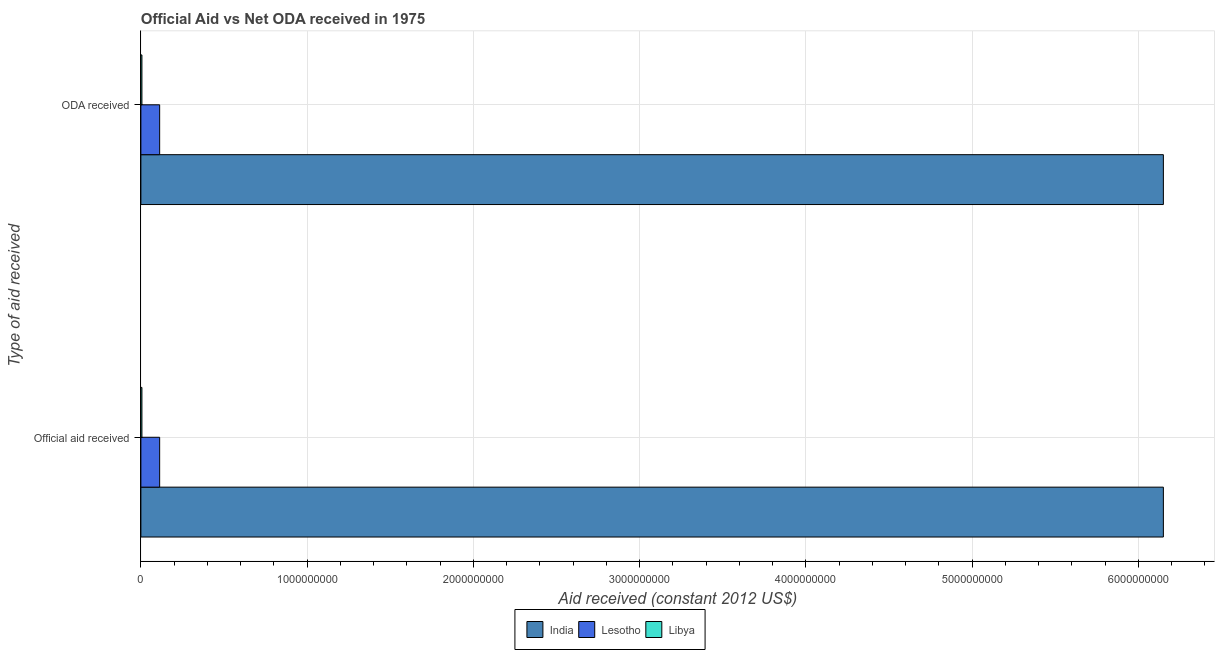How many different coloured bars are there?
Keep it short and to the point. 3. How many groups of bars are there?
Make the answer very short. 2. Are the number of bars per tick equal to the number of legend labels?
Offer a very short reply. Yes. How many bars are there on the 2nd tick from the top?
Provide a succinct answer. 3. What is the label of the 2nd group of bars from the top?
Make the answer very short. Official aid received. What is the official aid received in Libya?
Provide a succinct answer. 6.21e+06. Across all countries, what is the maximum oda received?
Offer a very short reply. 6.15e+09. Across all countries, what is the minimum oda received?
Your answer should be compact. 6.21e+06. In which country was the oda received maximum?
Offer a terse response. India. In which country was the official aid received minimum?
Keep it short and to the point. Libya. What is the total oda received in the graph?
Keep it short and to the point. 6.27e+09. What is the difference between the official aid received in India and that in Lesotho?
Keep it short and to the point. 6.04e+09. What is the difference between the oda received in Lesotho and the official aid received in India?
Keep it short and to the point. -6.04e+09. What is the average official aid received per country?
Your response must be concise. 2.09e+09. What is the ratio of the official aid received in Libya to that in Lesotho?
Make the answer very short. 0.06. Is the official aid received in Libya less than that in Lesotho?
Provide a short and direct response. Yes. What does the 3rd bar from the bottom in ODA received represents?
Your answer should be compact. Libya. How many bars are there?
Offer a very short reply. 6. Are the values on the major ticks of X-axis written in scientific E-notation?
Your answer should be compact. No. Does the graph contain any zero values?
Give a very brief answer. No. Does the graph contain grids?
Give a very brief answer. Yes. How many legend labels are there?
Provide a succinct answer. 3. What is the title of the graph?
Offer a very short reply. Official Aid vs Net ODA received in 1975 . What is the label or title of the X-axis?
Your answer should be compact. Aid received (constant 2012 US$). What is the label or title of the Y-axis?
Your response must be concise. Type of aid received. What is the Aid received (constant 2012 US$) in India in Official aid received?
Your answer should be compact. 6.15e+09. What is the Aid received (constant 2012 US$) of Lesotho in Official aid received?
Offer a terse response. 1.13e+08. What is the Aid received (constant 2012 US$) of Libya in Official aid received?
Keep it short and to the point. 6.21e+06. What is the Aid received (constant 2012 US$) in India in ODA received?
Your answer should be compact. 6.15e+09. What is the Aid received (constant 2012 US$) of Lesotho in ODA received?
Ensure brevity in your answer.  1.13e+08. What is the Aid received (constant 2012 US$) in Libya in ODA received?
Provide a succinct answer. 6.21e+06. Across all Type of aid received, what is the maximum Aid received (constant 2012 US$) in India?
Your answer should be very brief. 6.15e+09. Across all Type of aid received, what is the maximum Aid received (constant 2012 US$) of Lesotho?
Make the answer very short. 1.13e+08. Across all Type of aid received, what is the maximum Aid received (constant 2012 US$) in Libya?
Provide a short and direct response. 6.21e+06. Across all Type of aid received, what is the minimum Aid received (constant 2012 US$) in India?
Your response must be concise. 6.15e+09. Across all Type of aid received, what is the minimum Aid received (constant 2012 US$) of Lesotho?
Your answer should be compact. 1.13e+08. Across all Type of aid received, what is the minimum Aid received (constant 2012 US$) of Libya?
Keep it short and to the point. 6.21e+06. What is the total Aid received (constant 2012 US$) in India in the graph?
Keep it short and to the point. 1.23e+1. What is the total Aid received (constant 2012 US$) of Lesotho in the graph?
Your answer should be very brief. 2.26e+08. What is the total Aid received (constant 2012 US$) in Libya in the graph?
Your answer should be very brief. 1.24e+07. What is the difference between the Aid received (constant 2012 US$) of India in Official aid received and that in ODA received?
Your answer should be very brief. 0. What is the difference between the Aid received (constant 2012 US$) of Lesotho in Official aid received and that in ODA received?
Give a very brief answer. 0. What is the difference between the Aid received (constant 2012 US$) in India in Official aid received and the Aid received (constant 2012 US$) in Lesotho in ODA received?
Keep it short and to the point. 6.04e+09. What is the difference between the Aid received (constant 2012 US$) in India in Official aid received and the Aid received (constant 2012 US$) in Libya in ODA received?
Make the answer very short. 6.14e+09. What is the difference between the Aid received (constant 2012 US$) in Lesotho in Official aid received and the Aid received (constant 2012 US$) in Libya in ODA received?
Make the answer very short. 1.07e+08. What is the average Aid received (constant 2012 US$) of India per Type of aid received?
Provide a succinct answer. 6.15e+09. What is the average Aid received (constant 2012 US$) in Lesotho per Type of aid received?
Provide a short and direct response. 1.13e+08. What is the average Aid received (constant 2012 US$) of Libya per Type of aid received?
Ensure brevity in your answer.  6.21e+06. What is the difference between the Aid received (constant 2012 US$) in India and Aid received (constant 2012 US$) in Lesotho in Official aid received?
Ensure brevity in your answer.  6.04e+09. What is the difference between the Aid received (constant 2012 US$) in India and Aid received (constant 2012 US$) in Libya in Official aid received?
Your answer should be very brief. 6.14e+09. What is the difference between the Aid received (constant 2012 US$) in Lesotho and Aid received (constant 2012 US$) in Libya in Official aid received?
Provide a succinct answer. 1.07e+08. What is the difference between the Aid received (constant 2012 US$) in India and Aid received (constant 2012 US$) in Lesotho in ODA received?
Your answer should be very brief. 6.04e+09. What is the difference between the Aid received (constant 2012 US$) in India and Aid received (constant 2012 US$) in Libya in ODA received?
Ensure brevity in your answer.  6.14e+09. What is the difference between the Aid received (constant 2012 US$) of Lesotho and Aid received (constant 2012 US$) of Libya in ODA received?
Provide a short and direct response. 1.07e+08. What is the ratio of the Aid received (constant 2012 US$) of India in Official aid received to that in ODA received?
Your answer should be compact. 1. What is the ratio of the Aid received (constant 2012 US$) in Lesotho in Official aid received to that in ODA received?
Keep it short and to the point. 1. What is the difference between the highest and the second highest Aid received (constant 2012 US$) of Lesotho?
Keep it short and to the point. 0. What is the difference between the highest and the second highest Aid received (constant 2012 US$) of Libya?
Your answer should be compact. 0. What is the difference between the highest and the lowest Aid received (constant 2012 US$) in India?
Your answer should be compact. 0. What is the difference between the highest and the lowest Aid received (constant 2012 US$) of Libya?
Provide a short and direct response. 0. 